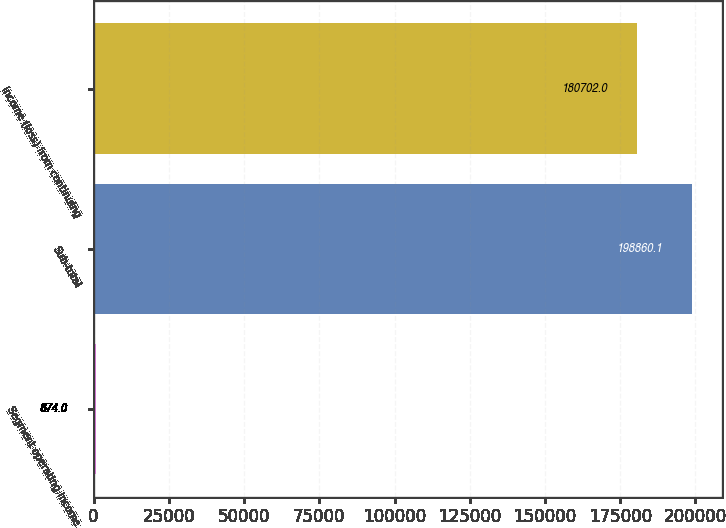Convert chart. <chart><loc_0><loc_0><loc_500><loc_500><bar_chart><fcel>Segment operating income<fcel>Sub-total<fcel>Income (loss) from continuing<nl><fcel>874<fcel>198860<fcel>180702<nl></chart> 